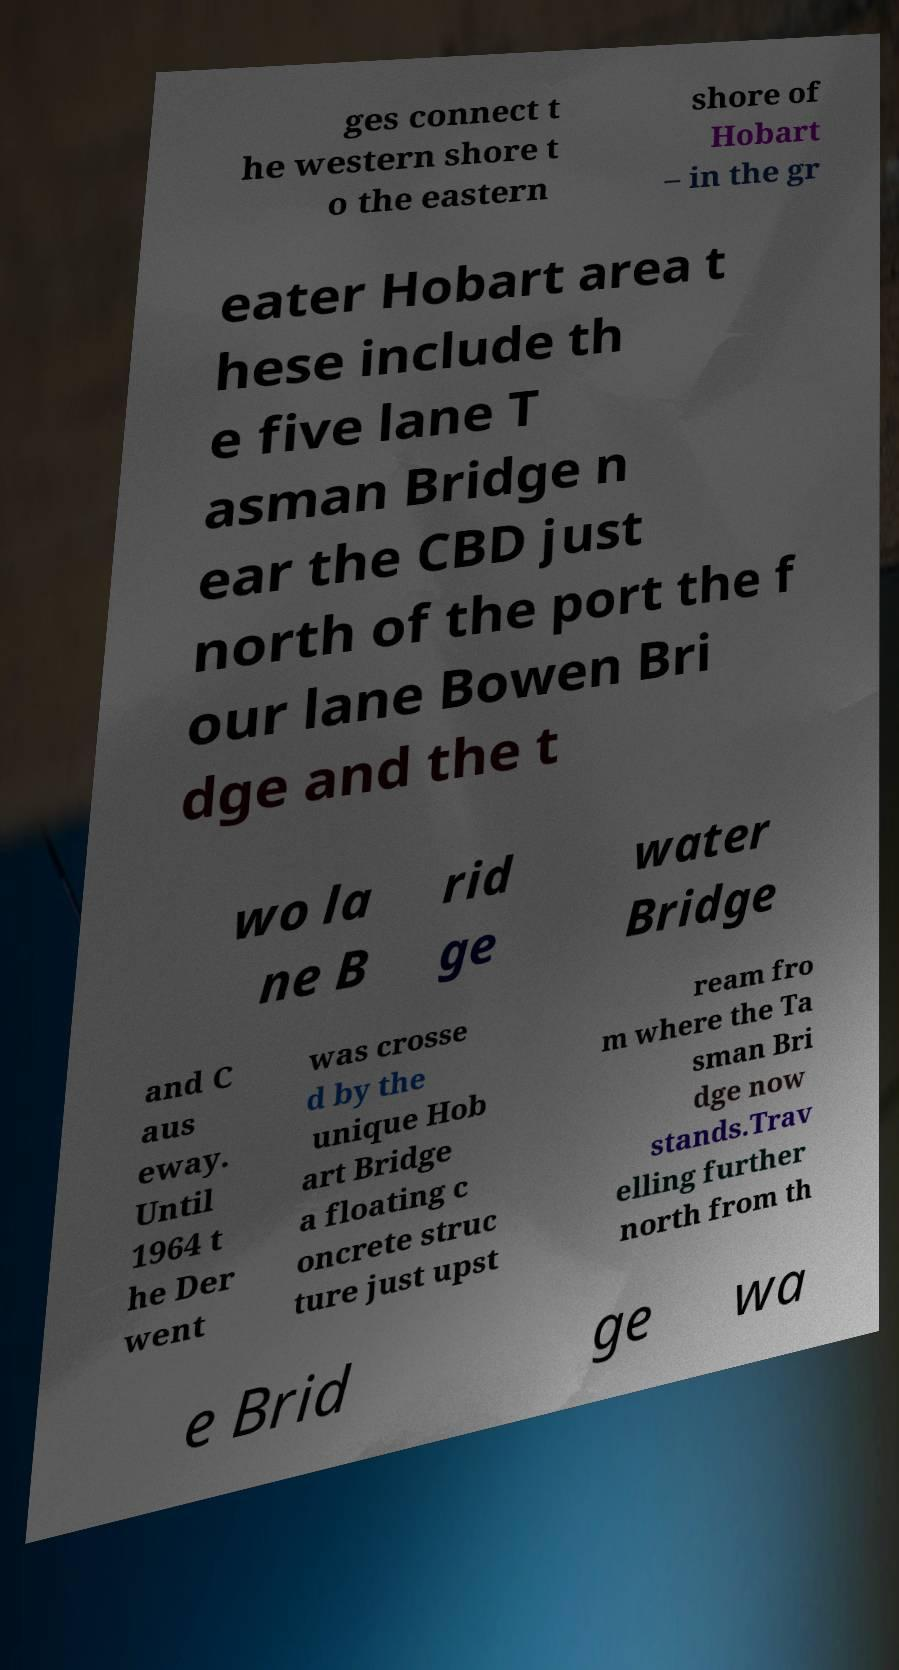Please read and relay the text visible in this image. What does it say? ges connect t he western shore t o the eastern shore of Hobart – in the gr eater Hobart area t hese include th e five lane T asman Bridge n ear the CBD just north of the port the f our lane Bowen Bri dge and the t wo la ne B rid ge water Bridge and C aus eway. Until 1964 t he Der went was crosse d by the unique Hob art Bridge a floating c oncrete struc ture just upst ream fro m where the Ta sman Bri dge now stands.Trav elling further north from th e Brid ge wa 